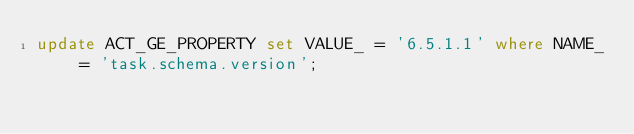<code> <loc_0><loc_0><loc_500><loc_500><_SQL_>update ACT_GE_PROPERTY set VALUE_ = '6.5.1.1' where NAME_ = 'task.schema.version';
</code> 